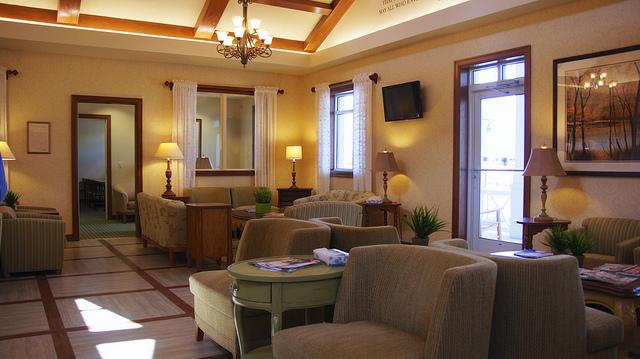What type room is this? Please explain your reasoning. lounge. There are many armchairs and tables so it's likely a lounge. 